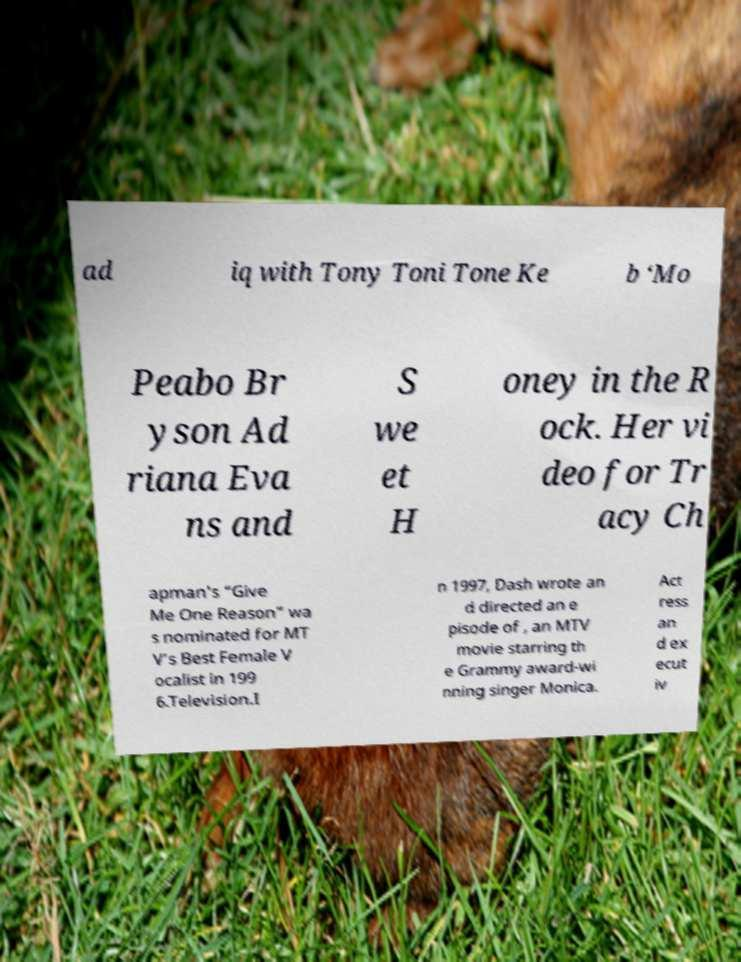I need the written content from this picture converted into text. Can you do that? ad iq with Tony Toni Tone Ke b ‘Mo Peabo Br yson Ad riana Eva ns and S we et H oney in the R ock. Her vi deo for Tr acy Ch apman's “Give Me One Reason” wa s nominated for MT V’s Best Female V ocalist in 199 6.Television.I n 1997, Dash wrote an d directed an e pisode of , an MTV movie starring th e Grammy award-wi nning singer Monica. Act ress an d ex ecut iv 